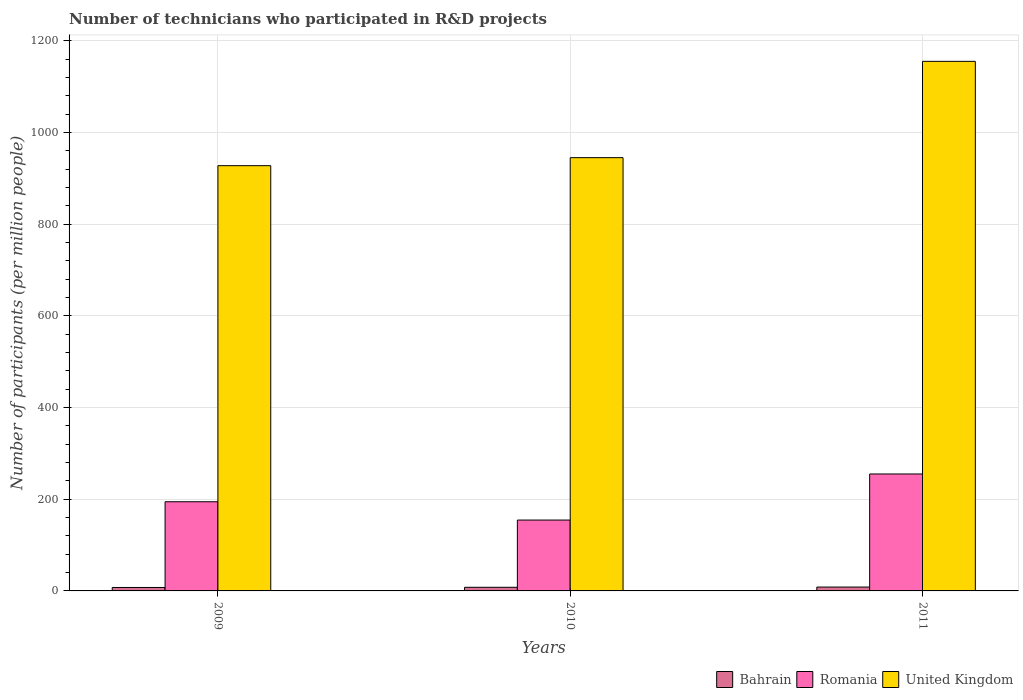How many different coloured bars are there?
Provide a short and direct response. 3. How many groups of bars are there?
Offer a terse response. 3. Are the number of bars per tick equal to the number of legend labels?
Your answer should be very brief. Yes. Are the number of bars on each tick of the X-axis equal?
Provide a succinct answer. Yes. How many bars are there on the 3rd tick from the left?
Your answer should be compact. 3. What is the label of the 1st group of bars from the left?
Make the answer very short. 2009. What is the number of technicians who participated in R&D projects in Romania in 2011?
Your response must be concise. 255.18. Across all years, what is the maximum number of technicians who participated in R&D projects in Romania?
Provide a succinct answer. 255.18. Across all years, what is the minimum number of technicians who participated in R&D projects in Romania?
Your response must be concise. 154.64. In which year was the number of technicians who participated in R&D projects in Romania maximum?
Keep it short and to the point. 2011. In which year was the number of technicians who participated in R&D projects in Bahrain minimum?
Ensure brevity in your answer.  2009. What is the total number of technicians who participated in R&D projects in United Kingdom in the graph?
Keep it short and to the point. 3028.77. What is the difference between the number of technicians who participated in R&D projects in Bahrain in 2009 and that in 2011?
Ensure brevity in your answer.  -0.9. What is the difference between the number of technicians who participated in R&D projects in Romania in 2011 and the number of technicians who participated in R&D projects in United Kingdom in 2009?
Give a very brief answer. -672.71. What is the average number of technicians who participated in R&D projects in Romania per year?
Your answer should be very brief. 201.47. In the year 2009, what is the difference between the number of technicians who participated in R&D projects in Bahrain and number of technicians who participated in R&D projects in United Kingdom?
Keep it short and to the point. -920.36. What is the ratio of the number of technicians who participated in R&D projects in United Kingdom in 2009 to that in 2010?
Offer a very short reply. 0.98. Is the number of technicians who participated in R&D projects in United Kingdom in 2010 less than that in 2011?
Offer a very short reply. Yes. What is the difference between the highest and the second highest number of technicians who participated in R&D projects in Bahrain?
Ensure brevity in your answer.  0.49. What is the difference between the highest and the lowest number of technicians who participated in R&D projects in Bahrain?
Give a very brief answer. 0.9. What does the 1st bar from the left in 2011 represents?
Your response must be concise. Bahrain. What does the 3rd bar from the right in 2009 represents?
Make the answer very short. Bahrain. Is it the case that in every year, the sum of the number of technicians who participated in R&D projects in Romania and number of technicians who participated in R&D projects in Bahrain is greater than the number of technicians who participated in R&D projects in United Kingdom?
Offer a terse response. No. How many years are there in the graph?
Your answer should be very brief. 3. What is the difference between two consecutive major ticks on the Y-axis?
Your response must be concise. 200. Are the values on the major ticks of Y-axis written in scientific E-notation?
Give a very brief answer. No. Does the graph contain any zero values?
Your response must be concise. No. Does the graph contain grids?
Keep it short and to the point. Yes. How are the legend labels stacked?
Your answer should be very brief. Horizontal. What is the title of the graph?
Provide a short and direct response. Number of technicians who participated in R&D projects. What is the label or title of the X-axis?
Offer a very short reply. Years. What is the label or title of the Y-axis?
Provide a succinct answer. Number of participants (per million people). What is the Number of participants (per million people) in Bahrain in 2009?
Offer a terse response. 7.52. What is the Number of participants (per million people) in Romania in 2009?
Make the answer very short. 194.59. What is the Number of participants (per million people) in United Kingdom in 2009?
Your answer should be very brief. 927.88. What is the Number of participants (per million people) in Bahrain in 2010?
Provide a succinct answer. 7.93. What is the Number of participants (per million people) in Romania in 2010?
Make the answer very short. 154.64. What is the Number of participants (per million people) of United Kingdom in 2010?
Offer a terse response. 945.36. What is the Number of participants (per million people) of Bahrain in 2011?
Provide a succinct answer. 8.42. What is the Number of participants (per million people) in Romania in 2011?
Provide a short and direct response. 255.18. What is the Number of participants (per million people) in United Kingdom in 2011?
Make the answer very short. 1155.52. Across all years, what is the maximum Number of participants (per million people) in Bahrain?
Provide a short and direct response. 8.42. Across all years, what is the maximum Number of participants (per million people) in Romania?
Keep it short and to the point. 255.18. Across all years, what is the maximum Number of participants (per million people) in United Kingdom?
Your answer should be very brief. 1155.52. Across all years, what is the minimum Number of participants (per million people) in Bahrain?
Give a very brief answer. 7.52. Across all years, what is the minimum Number of participants (per million people) of Romania?
Make the answer very short. 154.64. Across all years, what is the minimum Number of participants (per million people) in United Kingdom?
Give a very brief answer. 927.88. What is the total Number of participants (per million people) in Bahrain in the graph?
Make the answer very short. 23.87. What is the total Number of participants (per million people) in Romania in the graph?
Give a very brief answer. 604.4. What is the total Number of participants (per million people) in United Kingdom in the graph?
Give a very brief answer. 3028.77. What is the difference between the Number of participants (per million people) in Bahrain in 2009 and that in 2010?
Offer a terse response. -0.41. What is the difference between the Number of participants (per million people) in Romania in 2009 and that in 2010?
Give a very brief answer. 39.95. What is the difference between the Number of participants (per million people) in United Kingdom in 2009 and that in 2010?
Provide a succinct answer. -17.48. What is the difference between the Number of participants (per million people) of Bahrain in 2009 and that in 2011?
Your answer should be compact. -0.9. What is the difference between the Number of participants (per million people) of Romania in 2009 and that in 2011?
Offer a very short reply. -60.59. What is the difference between the Number of participants (per million people) of United Kingdom in 2009 and that in 2011?
Provide a short and direct response. -227.64. What is the difference between the Number of participants (per million people) of Bahrain in 2010 and that in 2011?
Offer a very short reply. -0.49. What is the difference between the Number of participants (per million people) in Romania in 2010 and that in 2011?
Your response must be concise. -100.54. What is the difference between the Number of participants (per million people) of United Kingdom in 2010 and that in 2011?
Make the answer very short. -210.16. What is the difference between the Number of participants (per million people) in Bahrain in 2009 and the Number of participants (per million people) in Romania in 2010?
Your answer should be compact. -147.12. What is the difference between the Number of participants (per million people) in Bahrain in 2009 and the Number of participants (per million people) in United Kingdom in 2010?
Give a very brief answer. -937.84. What is the difference between the Number of participants (per million people) in Romania in 2009 and the Number of participants (per million people) in United Kingdom in 2010?
Keep it short and to the point. -750.78. What is the difference between the Number of participants (per million people) in Bahrain in 2009 and the Number of participants (per million people) in Romania in 2011?
Provide a succinct answer. -247.66. What is the difference between the Number of participants (per million people) in Bahrain in 2009 and the Number of participants (per million people) in United Kingdom in 2011?
Provide a succinct answer. -1148. What is the difference between the Number of participants (per million people) of Romania in 2009 and the Number of participants (per million people) of United Kingdom in 2011?
Keep it short and to the point. -960.94. What is the difference between the Number of participants (per million people) of Bahrain in 2010 and the Number of participants (per million people) of Romania in 2011?
Offer a very short reply. -247.25. What is the difference between the Number of participants (per million people) in Bahrain in 2010 and the Number of participants (per million people) in United Kingdom in 2011?
Your answer should be very brief. -1147.6. What is the difference between the Number of participants (per million people) in Romania in 2010 and the Number of participants (per million people) in United Kingdom in 2011?
Provide a short and direct response. -1000.88. What is the average Number of participants (per million people) of Bahrain per year?
Keep it short and to the point. 7.96. What is the average Number of participants (per million people) of Romania per year?
Offer a terse response. 201.47. What is the average Number of participants (per million people) in United Kingdom per year?
Offer a terse response. 1009.59. In the year 2009, what is the difference between the Number of participants (per million people) in Bahrain and Number of participants (per million people) in Romania?
Your answer should be very brief. -187.07. In the year 2009, what is the difference between the Number of participants (per million people) of Bahrain and Number of participants (per million people) of United Kingdom?
Your answer should be very brief. -920.36. In the year 2009, what is the difference between the Number of participants (per million people) in Romania and Number of participants (per million people) in United Kingdom?
Keep it short and to the point. -733.3. In the year 2010, what is the difference between the Number of participants (per million people) in Bahrain and Number of participants (per million people) in Romania?
Your answer should be very brief. -146.71. In the year 2010, what is the difference between the Number of participants (per million people) of Bahrain and Number of participants (per million people) of United Kingdom?
Your response must be concise. -937.44. In the year 2010, what is the difference between the Number of participants (per million people) in Romania and Number of participants (per million people) in United Kingdom?
Offer a terse response. -790.73. In the year 2011, what is the difference between the Number of participants (per million people) of Bahrain and Number of participants (per million people) of Romania?
Your answer should be compact. -246.75. In the year 2011, what is the difference between the Number of participants (per million people) of Bahrain and Number of participants (per million people) of United Kingdom?
Provide a short and direct response. -1147.1. In the year 2011, what is the difference between the Number of participants (per million people) in Romania and Number of participants (per million people) in United Kingdom?
Offer a very short reply. -900.35. What is the ratio of the Number of participants (per million people) in Bahrain in 2009 to that in 2010?
Ensure brevity in your answer.  0.95. What is the ratio of the Number of participants (per million people) in Romania in 2009 to that in 2010?
Offer a very short reply. 1.26. What is the ratio of the Number of participants (per million people) of United Kingdom in 2009 to that in 2010?
Offer a terse response. 0.98. What is the ratio of the Number of participants (per million people) in Bahrain in 2009 to that in 2011?
Give a very brief answer. 0.89. What is the ratio of the Number of participants (per million people) of Romania in 2009 to that in 2011?
Give a very brief answer. 0.76. What is the ratio of the Number of participants (per million people) in United Kingdom in 2009 to that in 2011?
Offer a very short reply. 0.8. What is the ratio of the Number of participants (per million people) in Bahrain in 2010 to that in 2011?
Ensure brevity in your answer.  0.94. What is the ratio of the Number of participants (per million people) in Romania in 2010 to that in 2011?
Provide a succinct answer. 0.61. What is the ratio of the Number of participants (per million people) in United Kingdom in 2010 to that in 2011?
Keep it short and to the point. 0.82. What is the difference between the highest and the second highest Number of participants (per million people) of Bahrain?
Your response must be concise. 0.49. What is the difference between the highest and the second highest Number of participants (per million people) in Romania?
Keep it short and to the point. 60.59. What is the difference between the highest and the second highest Number of participants (per million people) of United Kingdom?
Ensure brevity in your answer.  210.16. What is the difference between the highest and the lowest Number of participants (per million people) of Bahrain?
Keep it short and to the point. 0.9. What is the difference between the highest and the lowest Number of participants (per million people) in Romania?
Provide a succinct answer. 100.54. What is the difference between the highest and the lowest Number of participants (per million people) in United Kingdom?
Your response must be concise. 227.64. 